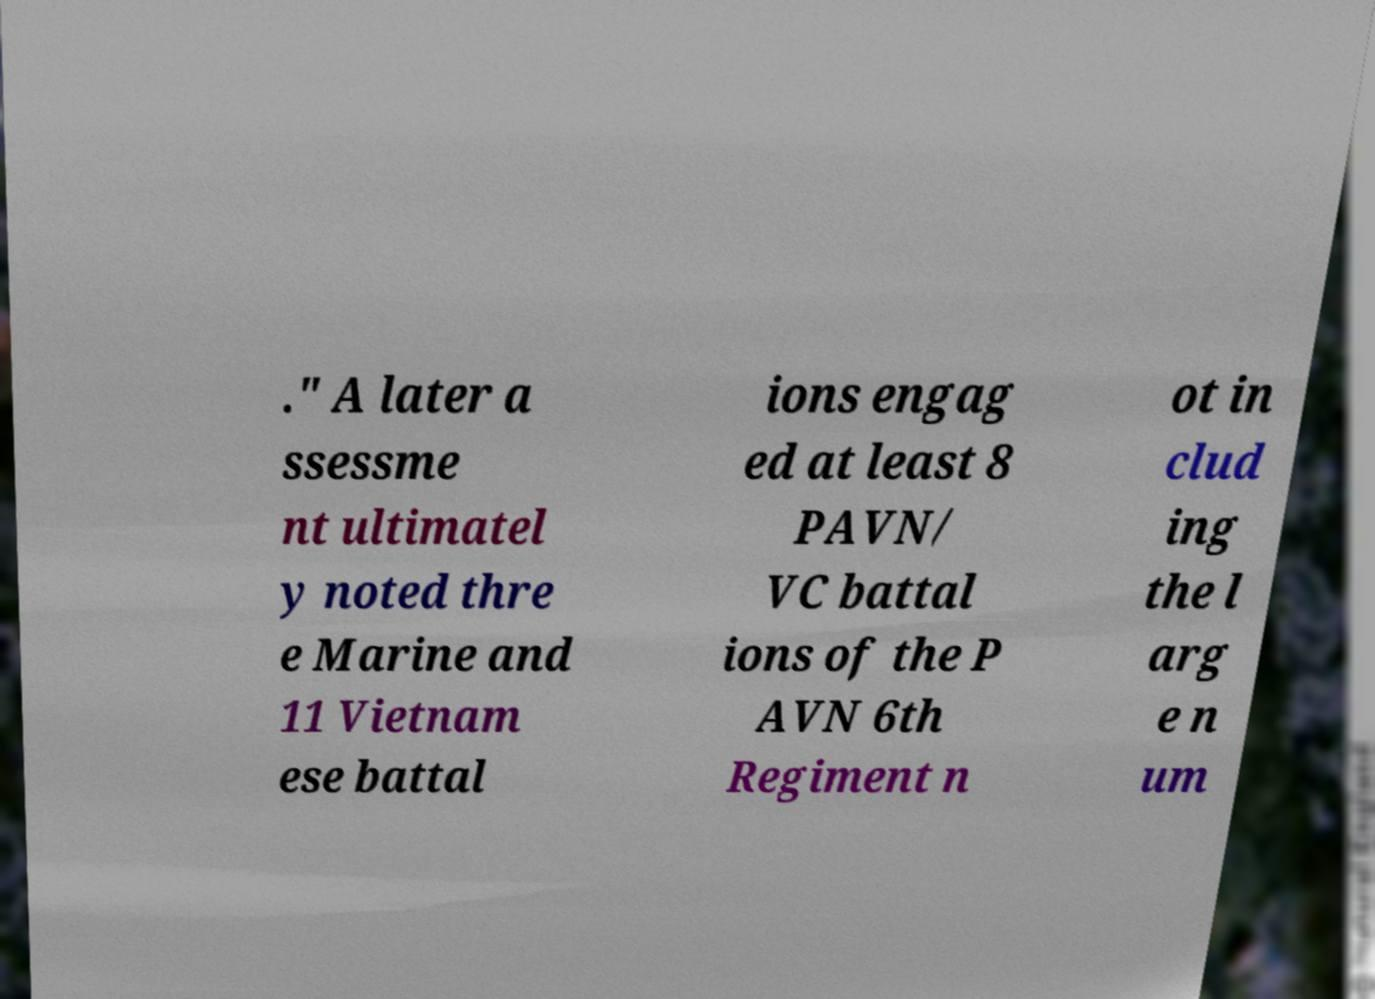There's text embedded in this image that I need extracted. Can you transcribe it verbatim? ." A later a ssessme nt ultimatel y noted thre e Marine and 11 Vietnam ese battal ions engag ed at least 8 PAVN/ VC battal ions of the P AVN 6th Regiment n ot in clud ing the l arg e n um 